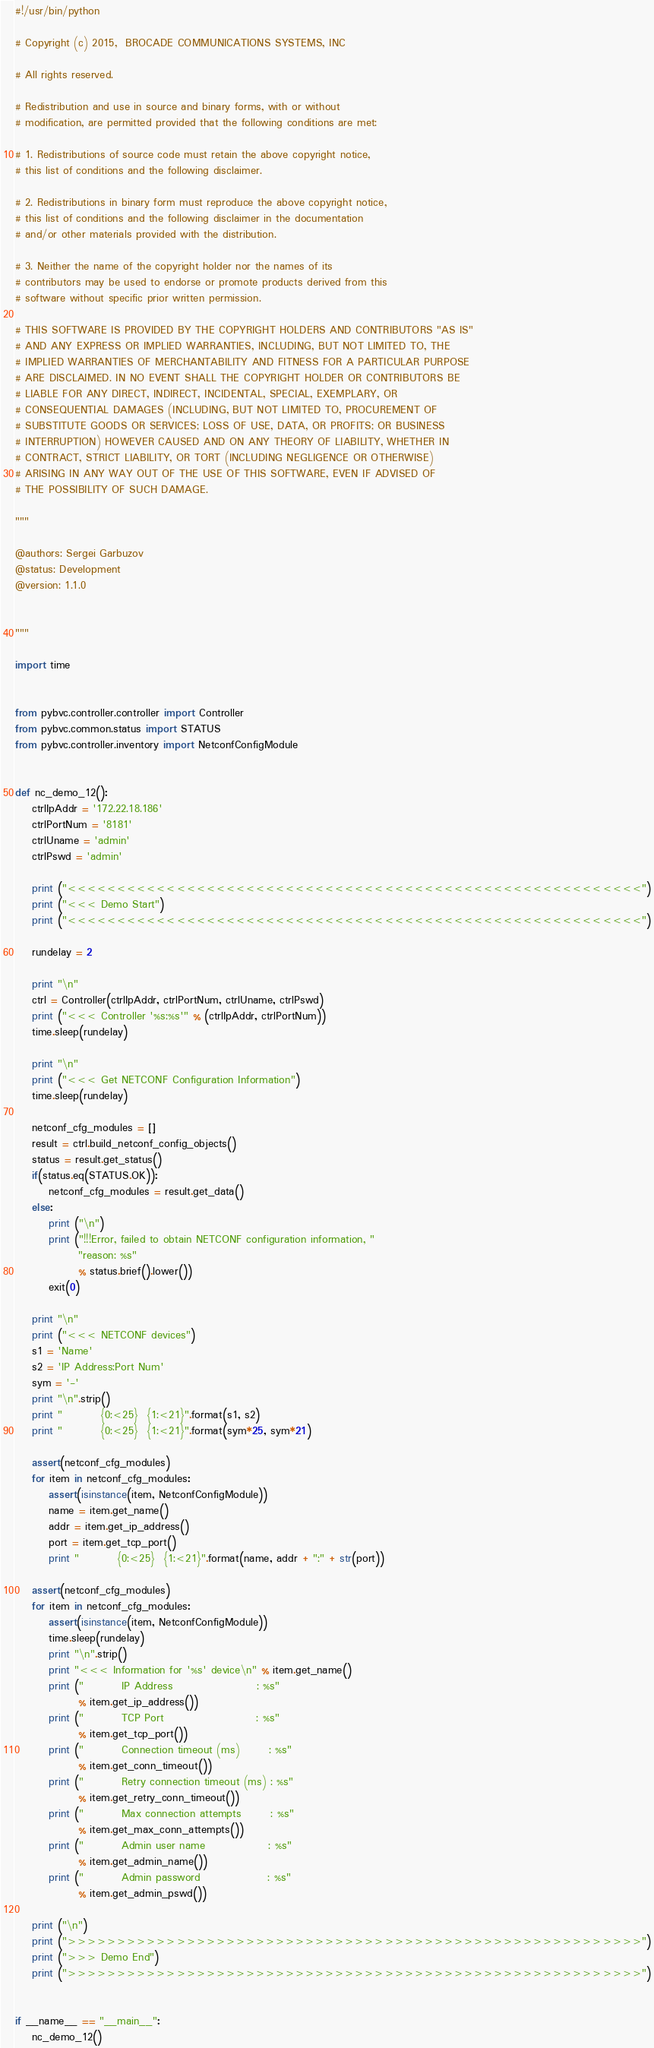Convert code to text. <code><loc_0><loc_0><loc_500><loc_500><_Python_>#!/usr/bin/python

# Copyright (c) 2015,  BROCADE COMMUNICATIONS SYSTEMS, INC

# All rights reserved.

# Redistribution and use in source and binary forms, with or without
# modification, are permitted provided that the following conditions are met:

# 1. Redistributions of source code must retain the above copyright notice,
# this list of conditions and the following disclaimer.

# 2. Redistributions in binary form must reproduce the above copyright notice,
# this list of conditions and the following disclaimer in the documentation
# and/or other materials provided with the distribution.

# 3. Neither the name of the copyright holder nor the names of its
# contributors may be used to endorse or promote products derived from this
# software without specific prior written permission.

# THIS SOFTWARE IS PROVIDED BY THE COPYRIGHT HOLDERS AND CONTRIBUTORS "AS IS"
# AND ANY EXPRESS OR IMPLIED WARRANTIES, INCLUDING, BUT NOT LIMITED TO, THE
# IMPLIED WARRANTIES OF MERCHANTABILITY AND FITNESS FOR A PARTICULAR PURPOSE
# ARE DISCLAIMED. IN NO EVENT SHALL THE COPYRIGHT HOLDER OR CONTRIBUTORS BE
# LIABLE FOR ANY DIRECT, INDIRECT, INCIDENTAL, SPECIAL, EXEMPLARY, OR
# CONSEQUENTIAL DAMAGES (INCLUDING, BUT NOT LIMITED TO, PROCUREMENT OF
# SUBSTITUTE GOODS OR SERVICES; LOSS OF USE, DATA, OR PROFITS; OR BUSINESS
# INTERRUPTION) HOWEVER CAUSED AND ON ANY THEORY OF LIABILITY, WHETHER IN
# CONTRACT, STRICT LIABILITY, OR TORT (INCLUDING NEGLIGENCE OR OTHERWISE)
# ARISING IN ANY WAY OUT OF THE USE OF THIS SOFTWARE, EVEN IF ADVISED OF
# THE POSSIBILITY OF SUCH DAMAGE.

"""

@authors: Sergei Garbuzov
@status: Development
@version: 1.1.0


"""

import time


from pybvc.controller.controller import Controller
from pybvc.common.status import STATUS
from pybvc.controller.inventory import NetconfConfigModule


def nc_demo_12():
    ctrlIpAddr = '172.22.18.186'
    ctrlPortNum = '8181'
    ctrlUname = 'admin'
    ctrlPswd = 'admin'

    print ("<<<<<<<<<<<<<<<<<<<<<<<<<<<<<<<<<<<<<<<<<<<<<<<<<<<<<<<<<<")
    print ("<<< Demo Start")
    print ("<<<<<<<<<<<<<<<<<<<<<<<<<<<<<<<<<<<<<<<<<<<<<<<<<<<<<<<<<<")

    rundelay = 2

    print "\n"
    ctrl = Controller(ctrlIpAddr, ctrlPortNum, ctrlUname, ctrlPswd)
    print ("<<< Controller '%s:%s'" % (ctrlIpAddr, ctrlPortNum))
    time.sleep(rundelay)

    print "\n"
    print ("<<< Get NETCONF Configuration Information")
    time.sleep(rundelay)

    netconf_cfg_modules = []
    result = ctrl.build_netconf_config_objects()
    status = result.get_status()
    if(status.eq(STATUS.OK)):
        netconf_cfg_modules = result.get_data()
    else:
        print ("\n")
        print ("!!!Error, failed to obtain NETCONF configuration information, "
               "reason: %s"
               % status.brief().lower())
        exit(0)

    print "\n"
    print ("<<< NETCONF devices")
    s1 = 'Name'
    s2 = 'IP Address:Port Num'
    sym = '-'
    print "\n".strip()
    print "         {0:<25}  {1:<21}".format(s1, s2)
    print "         {0:<25}  {1:<21}".format(sym*25, sym*21)

    assert(netconf_cfg_modules)
    for item in netconf_cfg_modules:
        assert(isinstance(item, NetconfConfigModule))
        name = item.get_name()
        addr = item.get_ip_address()
        port = item.get_tcp_port()
        print "         {0:<25}  {1:<21}".format(name, addr + ":" + str(port))

    assert(netconf_cfg_modules)
    for item in netconf_cfg_modules:
        assert(isinstance(item, NetconfConfigModule))
        time.sleep(rundelay)
        print "\n".strip()
        print "<<< Information for '%s' device\n" % item.get_name()
        print ("         IP Address                    : %s"
               % item.get_ip_address())
        print ("         TCP Port                      : %s"
               % item.get_tcp_port())
        print ("         Connection timeout (ms)       : %s"
               % item.get_conn_timeout())
        print ("         Retry connection timeout (ms) : %s"
               % item.get_retry_conn_timeout())
        print ("         Max connection attempts       : %s"
               % item.get_max_conn_attempts())
        print ("         Admin user name               : %s"
               % item.get_admin_name())
        print ("         Admin password                : %s"
               % item.get_admin_pswd())

    print ("\n")
    print (">>>>>>>>>>>>>>>>>>>>>>>>>>>>>>>>>>>>>>>>>>>>>>>>>>>>>>>>>>")
    print (">>> Demo End")
    print (">>>>>>>>>>>>>>>>>>>>>>>>>>>>>>>>>>>>>>>>>>>>>>>>>>>>>>>>>>")


if __name__ == "__main__":
    nc_demo_12()
</code> 